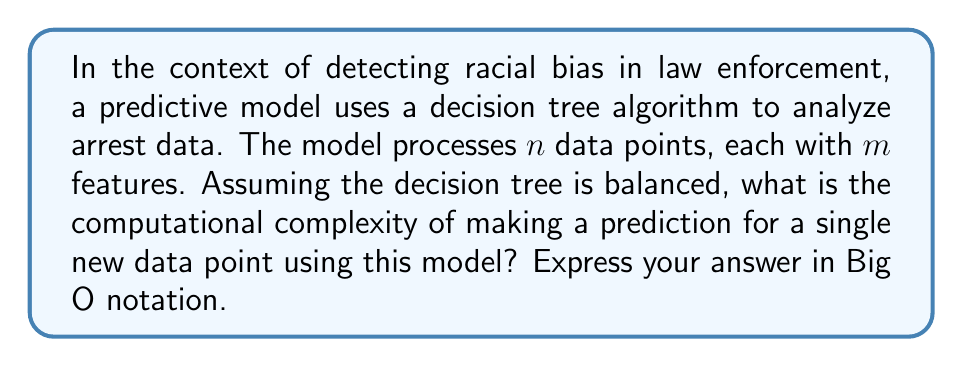Could you help me with this problem? Let's approach this step-by-step:

1) In a balanced decision tree, the depth of the tree is logarithmic in the number of leaf nodes. The number of leaf nodes is at most $n$, where $n$ is the number of data points used to train the model.

2) The depth of the tree is therefore $O(\log n)$.

3) At each node of the tree, the algorithm needs to make a decision based on one of the $m$ features. This operation takes $O(1)$ time.

4) To make a prediction, the algorithm starts at the root and traverses down to a leaf node. At each step, it makes one decision.

5) The number of decisions it needs to make is equal to the depth of the tree, which we determined to be $O(\log n)$.

6) Therefore, the total time complexity for making a prediction is:

   $$O(\log n) \cdot O(1) = O(\log n)$$

This complexity reflects the time it takes to traverse the decision tree from root to leaf, making a constant-time decision at each node.
Answer: $O(\log n)$ 